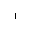Convert formula to latex. <formula><loc_0><loc_0><loc_500><loc_500>^ { 1 }</formula> 